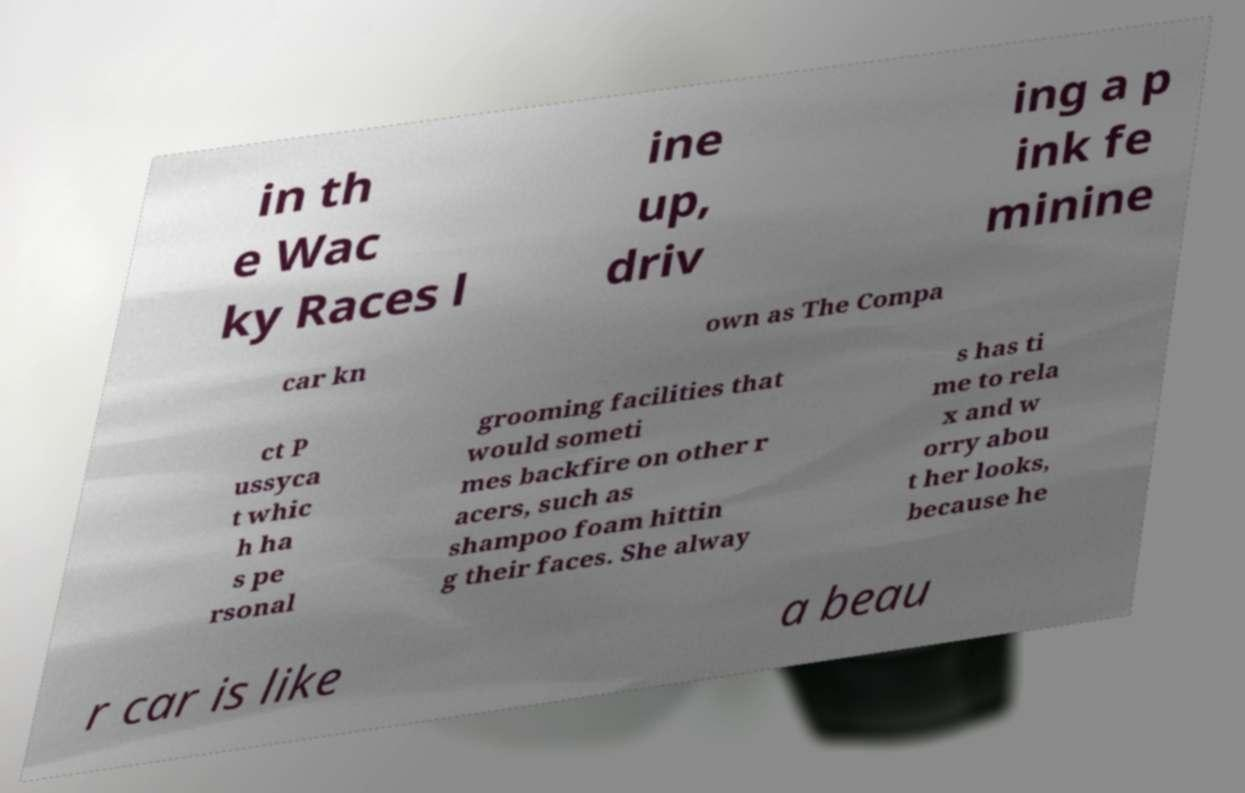Please read and relay the text visible in this image. What does it say? in th e Wac ky Races l ine up, driv ing a p ink fe minine car kn own as The Compa ct P ussyca t whic h ha s pe rsonal grooming facilities that would someti mes backfire on other r acers, such as shampoo foam hittin g their faces. She alway s has ti me to rela x and w orry abou t her looks, because he r car is like a beau 